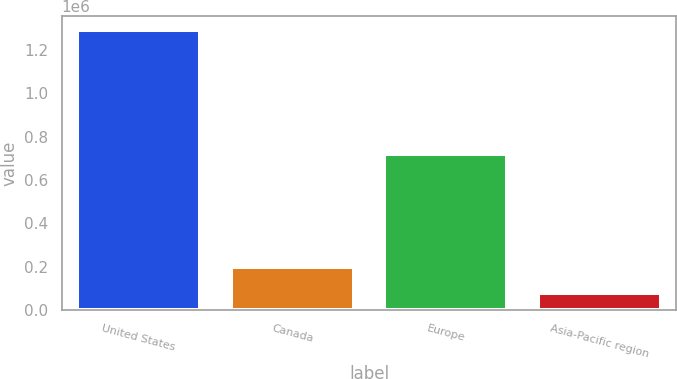<chart> <loc_0><loc_0><loc_500><loc_500><bar_chart><fcel>United States<fcel>Canada<fcel>Europe<fcel>Asia-Pacific region<nl><fcel>1.29191e+06<fcel>198965<fcel>722140<fcel>77527<nl></chart> 